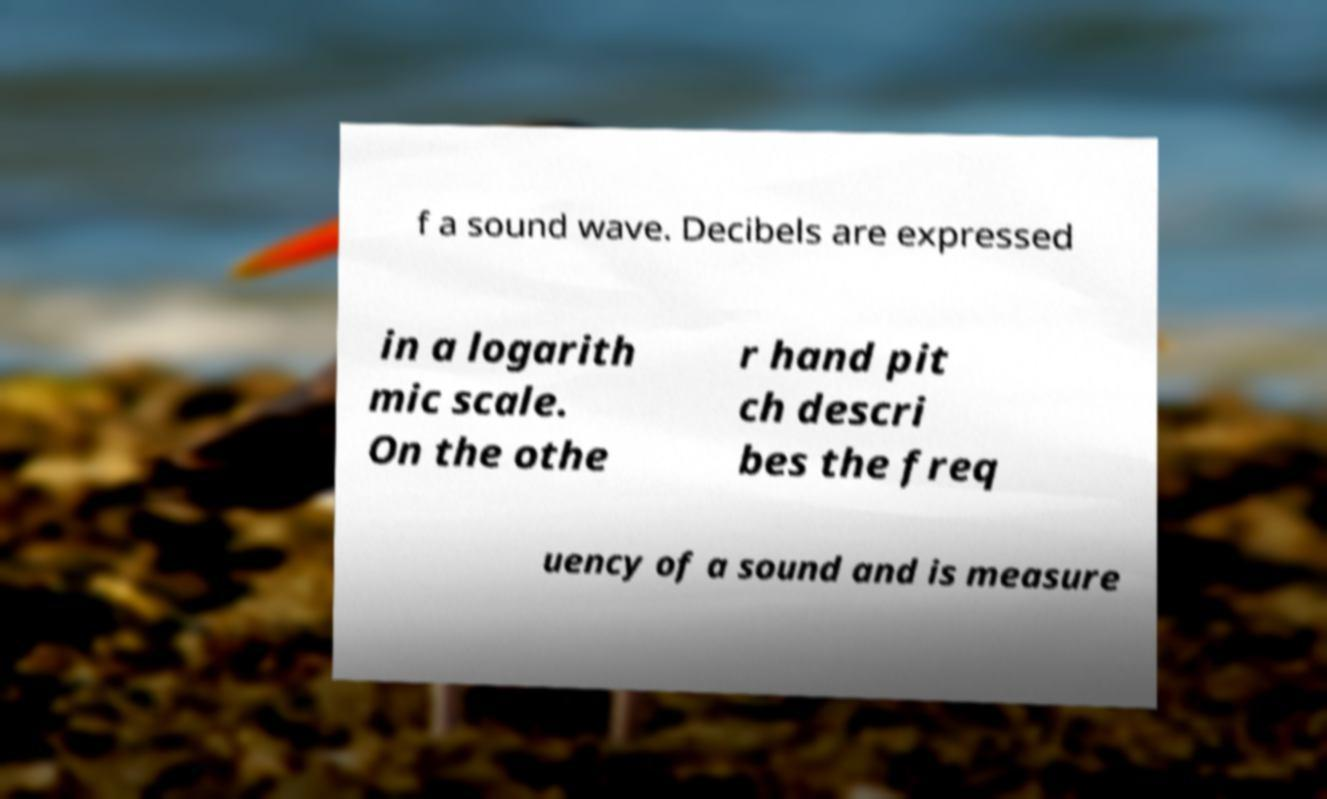There's text embedded in this image that I need extracted. Can you transcribe it verbatim? f a sound wave. Decibels are expressed in a logarith mic scale. On the othe r hand pit ch descri bes the freq uency of a sound and is measure 